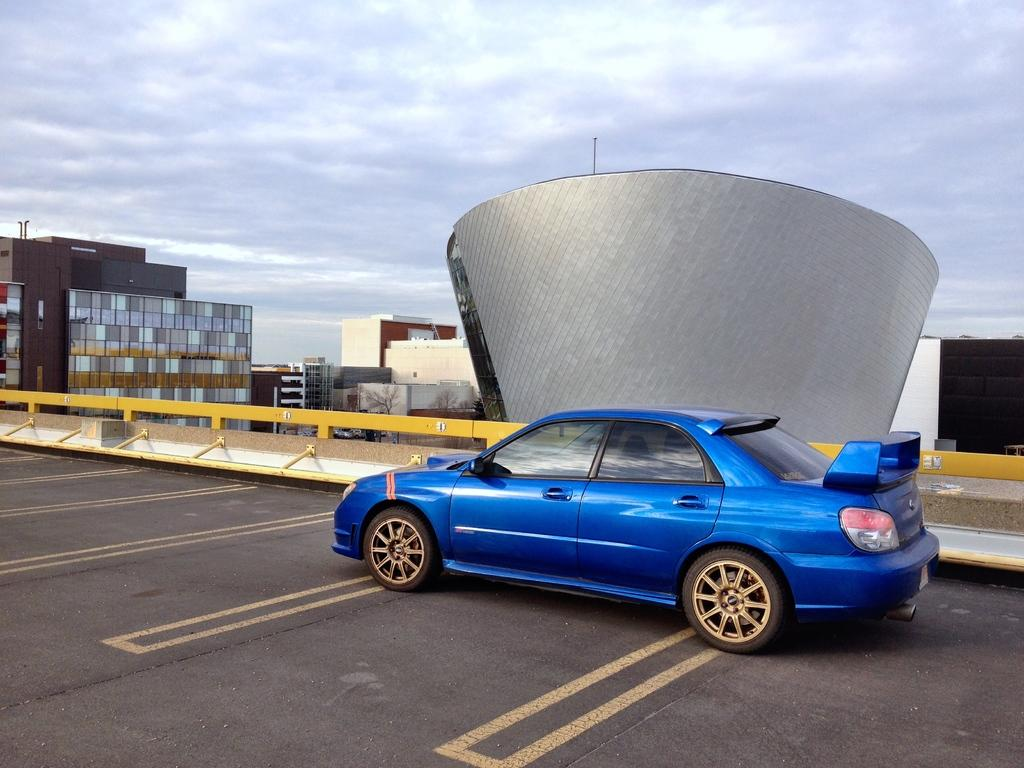What color is the car in the image? The car in the image is blue. Where is the car located in the image? The car is in the center of the image. What surface is the car on? The car is on the road. What can be seen in the background of the image? There are buildings in the background of the image. What type of scent can be detected coming from the car in the image? There is no information about a scent in the image, so it cannot be determined. 